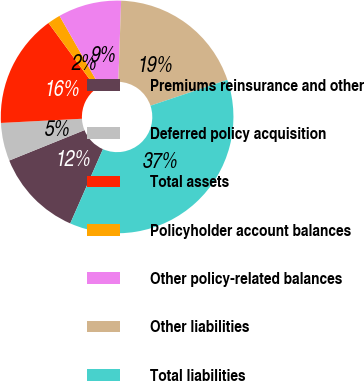Convert chart to OTSL. <chart><loc_0><loc_0><loc_500><loc_500><pie_chart><fcel>Premiums reinsurance and other<fcel>Deferred policy acquisition<fcel>Total assets<fcel>Policyholder account balances<fcel>Other policy-related balances<fcel>Other liabilities<fcel>Total liabilities<nl><fcel>12.29%<fcel>5.29%<fcel>15.78%<fcel>1.8%<fcel>8.79%<fcel>19.28%<fcel>36.76%<nl></chart> 